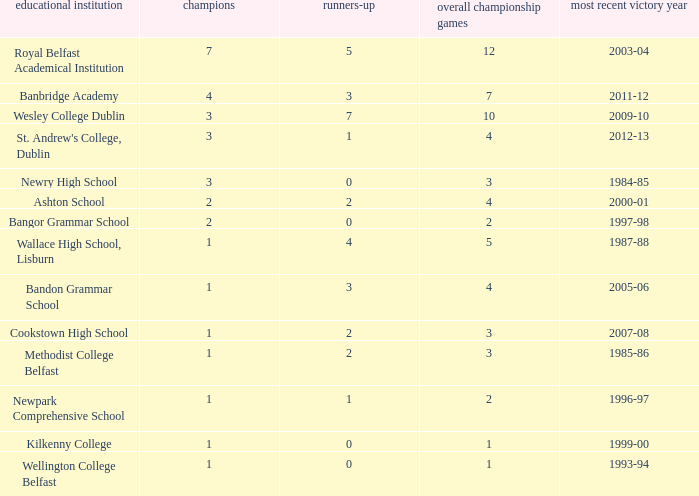How many times was banbridge academy the winner? 1.0. 